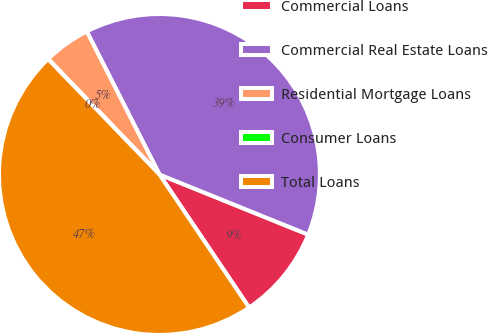Convert chart to OTSL. <chart><loc_0><loc_0><loc_500><loc_500><pie_chart><fcel>Commercial Loans<fcel>Commercial Real Estate Loans<fcel>Residential Mortgage Loans<fcel>Consumer Loans<fcel>Total Loans<nl><fcel>9.45%<fcel>38.6%<fcel>4.73%<fcel>0.01%<fcel>47.22%<nl></chart> 